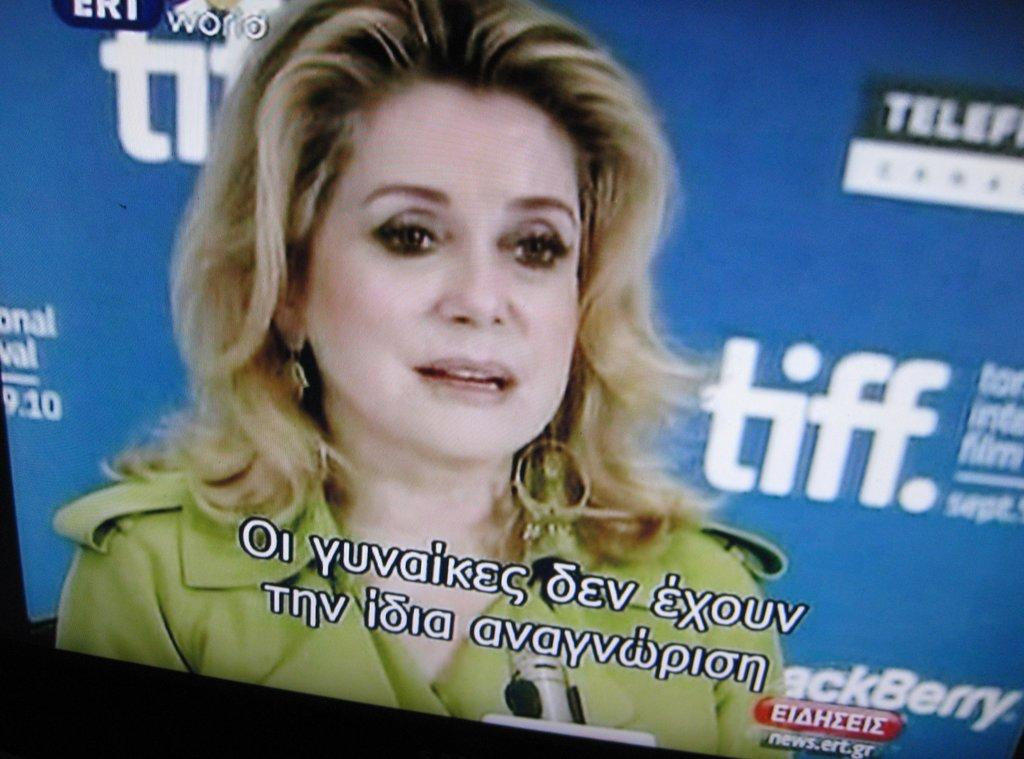What is the main object in the image? There is a monitor in the image. What is being displayed on the monitor? A woman is displayed on the monitor, along with text. What can be seen in the background of the image? There is a banner in the background of the image. What is written on the banner? There is text on the banner. What type of sweater is the woman wearing in the image? There is no woman present in the image; the woman is displayed on the monitor. Is it raining in the image? There is no indication of rain in the image; it only features a monitor, a woman displayed on the monitor, text on the monitor, a banner, and text on the banner. 